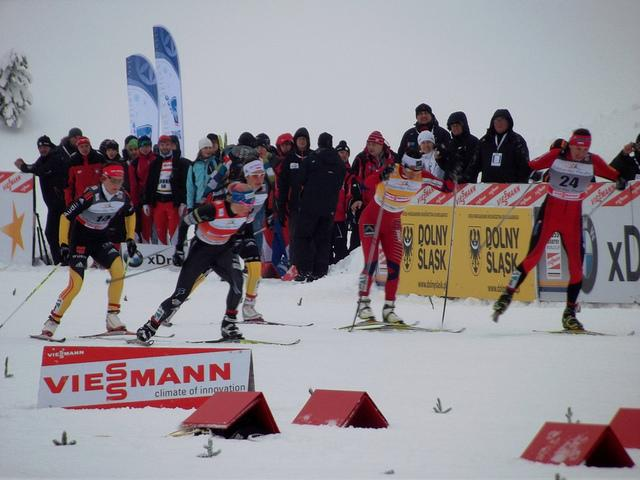What country does the sponsor closest to the camera have it's headquarters located? Please explain your reasoning. germany. Israel in gamning. 